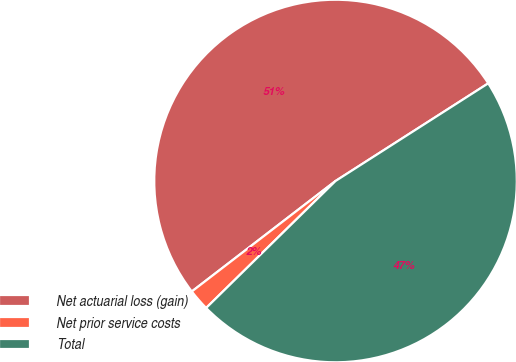Convert chart to OTSL. <chart><loc_0><loc_0><loc_500><loc_500><pie_chart><fcel>Net actuarial loss (gain)<fcel>Net prior service costs<fcel>Total<nl><fcel>51.37%<fcel>1.92%<fcel>46.7%<nl></chart> 